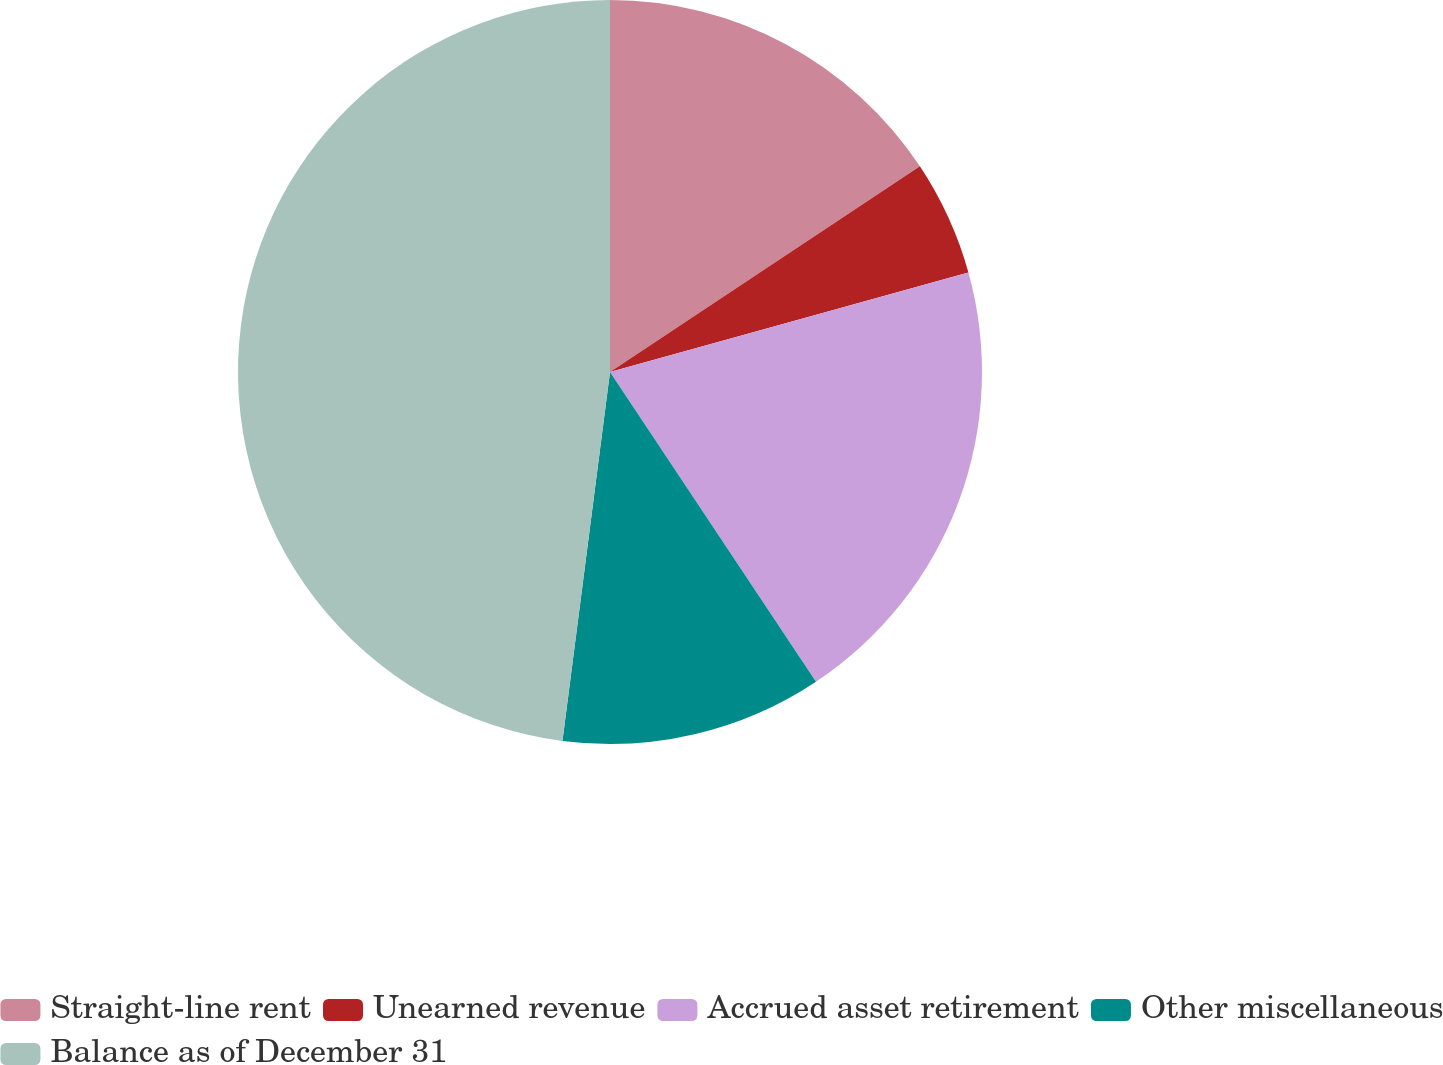<chart> <loc_0><loc_0><loc_500><loc_500><pie_chart><fcel>Straight-line rent<fcel>Unearned revenue<fcel>Accrued asset retirement<fcel>Other miscellaneous<fcel>Balance as of December 31<nl><fcel>15.67%<fcel>5.02%<fcel>19.97%<fcel>11.38%<fcel>47.96%<nl></chart> 